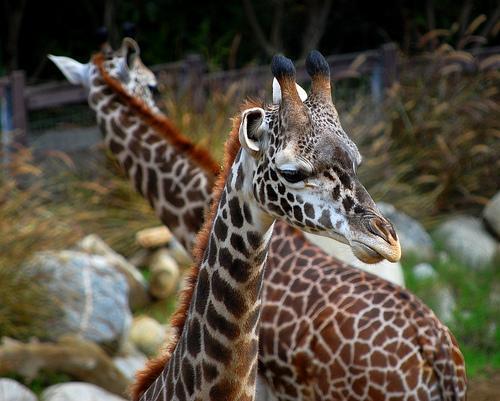How many giraffes are shown?
Give a very brief answer. 2. How many horns do the giraffes have?
Give a very brief answer. 2. 